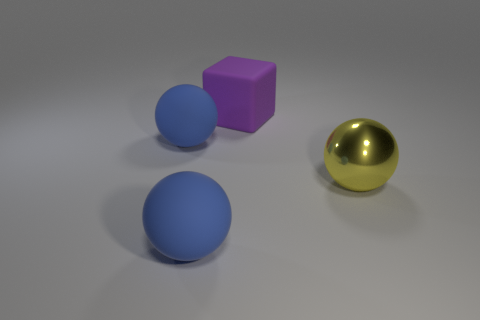Does the surface texture of the purple block differ from the balls, and if so, how? The surface texture of the purple block appears to be matte, absorbing more light than it reflects, which contrasts with the glossy finish of the balls that have a clear reflection and highlights, indicating a smoother surface. 